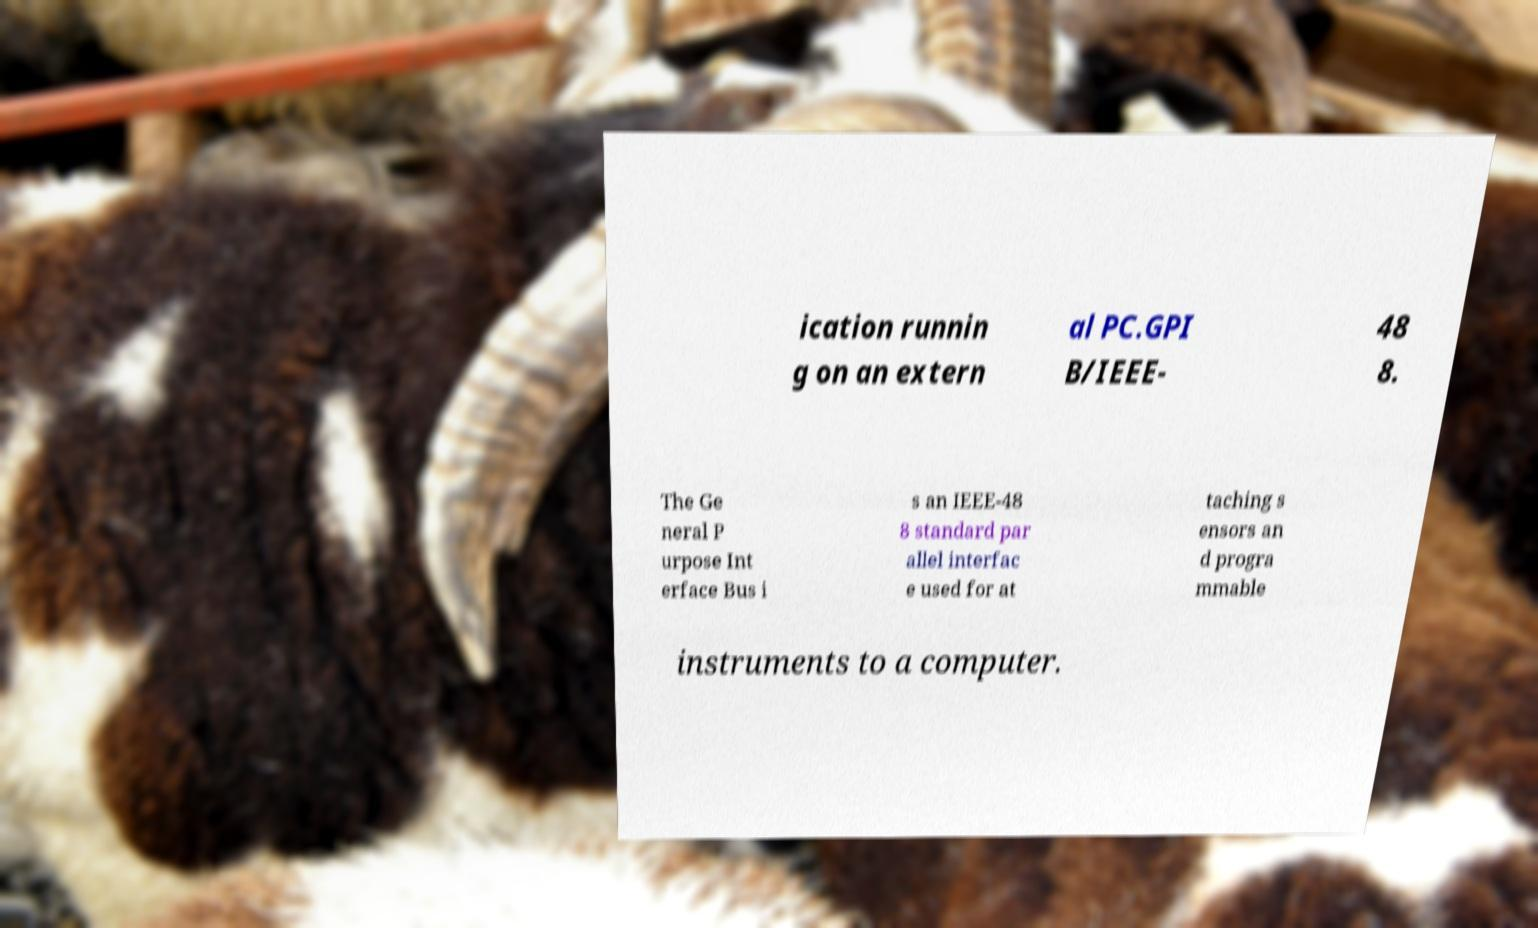Could you assist in decoding the text presented in this image and type it out clearly? ication runnin g on an extern al PC.GPI B/IEEE- 48 8. The Ge neral P urpose Int erface Bus i s an IEEE-48 8 standard par allel interfac e used for at taching s ensors an d progra mmable instruments to a computer. 